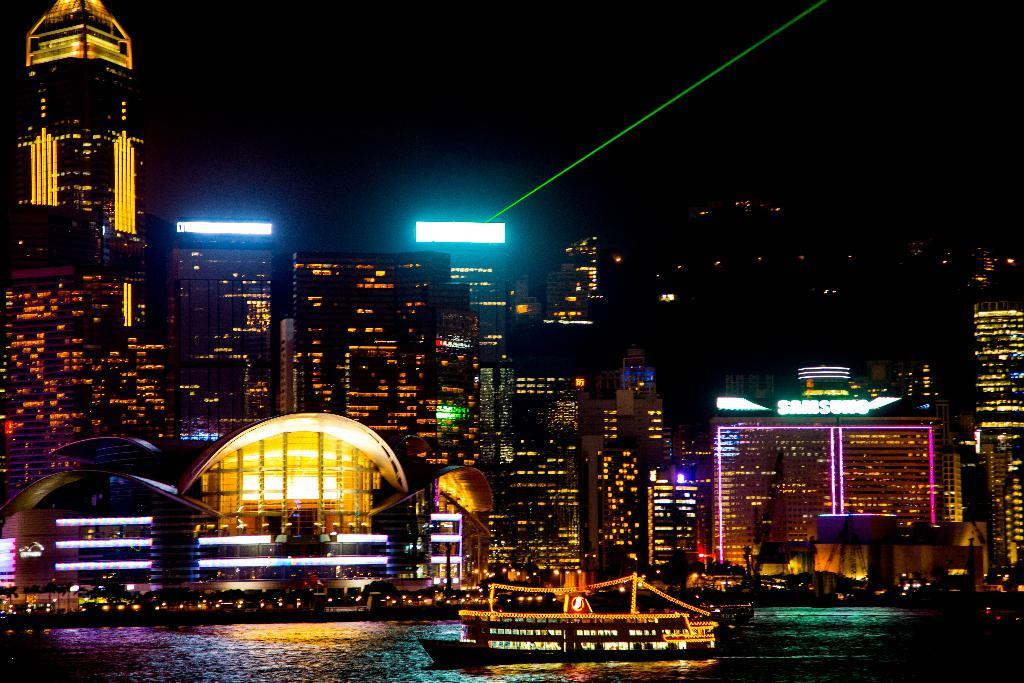What is the setting of the image? The image is a night view of a city. What can be seen in the image besides the cityscape? There are many buildings and a ship moving on the water surface in the front of the image. What is the color scheme of the image? The image is colorful. Can you describe the organizations visible in the image? Unfortunately, the provided facts do not mention any specific organizations in the image. What type of tin is being used to protect the skin of the people in the image? There is no mention of tin or skin protection in the image. The image features a night view of a city with buildings, a ship, and a colorful setting. 